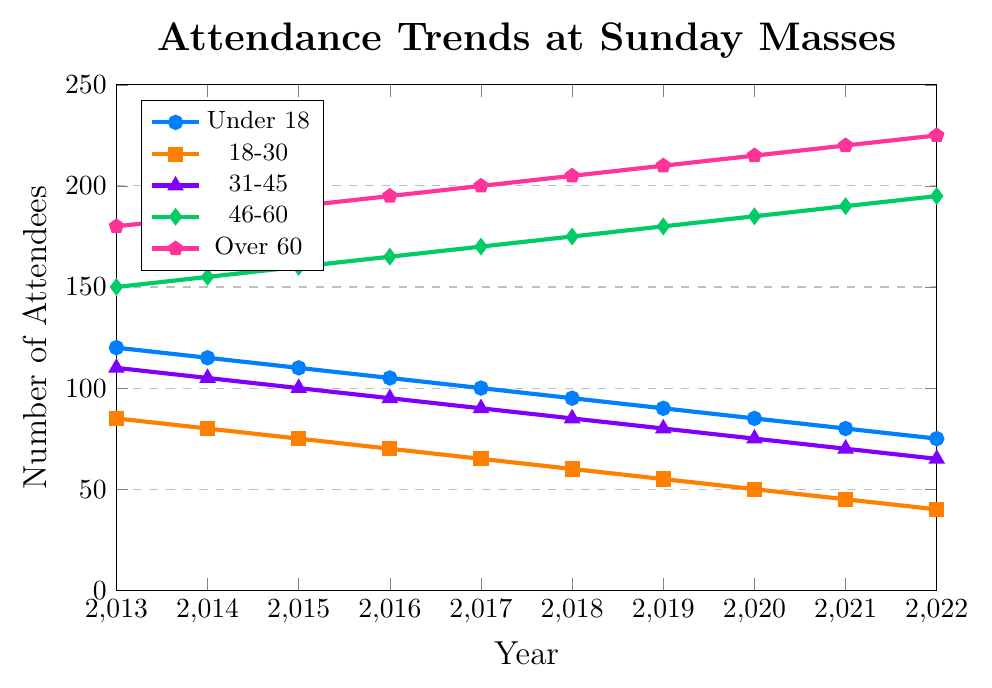What year did the age group '18-30' have 55 attendees? Locate the '18-30' line marked by squares, follow it until it intersects with the y-axis value of 55. This intersection point corresponds with the year 2019 on the x-axis.
Answer: 2019 Did the 'Over 60' age group ever have fewer attendees than the 'Under 18' age group? Observe the trends of both groups over the years. The 'Over 60' line (pink pentagons) remains above the 'Under 18' line (blue circles) throughout the decade, indicating no instance where 'Over 60' had fewer attendees than 'Under 18'.
Answer: No Which age group showed a continuous increase in attendance from 2013 to 2022? Track each line to identify any positive continuous trends. The 'Over 60' group, marked with pink pentagons, shows a steady increase each year.
Answer: Over 60 How many more attendees did the '46-60' age group have compared to the 'Under 18' age group in 2020? Locate the attendance values for '46-60' and 'Under 18' in 2020: 185 and 85 respectively. Subtract 'Under 18' from '46-60' (185 - 85).
Answer: 100 What's the average number of attendees for the '31-45' age group over the decade? Sum the values for '31-45': (110 + 105 + 100 + 95 + 90 + 85 + 80 + 75 + 70 + 65) = 875. Divide by the number of years (10).
Answer: 87.5 In what year did the total attendance across all age groups reach the highest value? Calculate total attendance for each year and compare: 2013 (645), 2014 (640), 2015 (635), 2016 (630), 2017 (625), 2018 (620), 2019 (615), 2020 (610), 2021 (605), 2022 (600). The highest value occurs in 2013.
Answer: 2013 Which age group had the steepest decline in attendance from 2013 to 2022? Evaluate the slope of each line from 2013 to 2022. The 'Under 18' group (blue circles) decreased from 120 to 75 (a difference of 45), indicating the steepest decline.
Answer: Under 18 Did any age group have a year where attendance did not change from the previous year? Observe each line for flat segments (zero slope). From 2013 to 2022, every group's attendance changes each year without any flat segments.
Answer: No What is the median attendance value for the '18-30' age group over the decade? List the attendance values for '18-30': (85, 80, 75, 70, 65, 60, 55, 50, 45, 40). The middle two numbers (fifth and sixth) are 65 and 60. The median is (65 + 60) / 2.
Answer: 62.5 